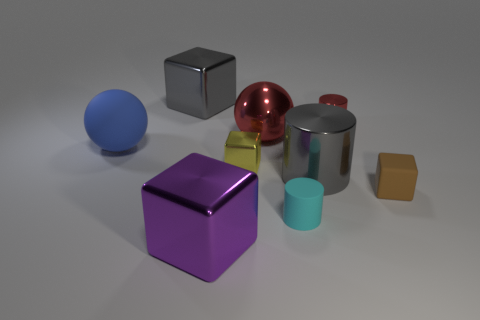Is there anything else that has the same material as the brown block?
Provide a succinct answer. Yes. Are there fewer large blue rubber balls behind the large gray cube than large red shiny things?
Give a very brief answer. Yes. Are there more large gray blocks that are right of the purple metallic thing than small brown cubes to the left of the tiny red thing?
Make the answer very short. No. Are there any other things that are the same color as the large matte object?
Make the answer very short. No. There is a big gray object in front of the big blue thing; what material is it?
Make the answer very short. Metal. Do the yellow object and the cyan cylinder have the same size?
Keep it short and to the point. Yes. How many other objects are the same size as the brown matte thing?
Your response must be concise. 3. Does the tiny rubber block have the same color as the big matte thing?
Your response must be concise. No. There is a big gray shiny object to the left of the red thing that is to the left of the gray shiny object that is in front of the large matte thing; what shape is it?
Give a very brief answer. Cube. What number of objects are matte objects on the right side of the small cyan cylinder or large gray objects that are in front of the big red sphere?
Your answer should be very brief. 2. 